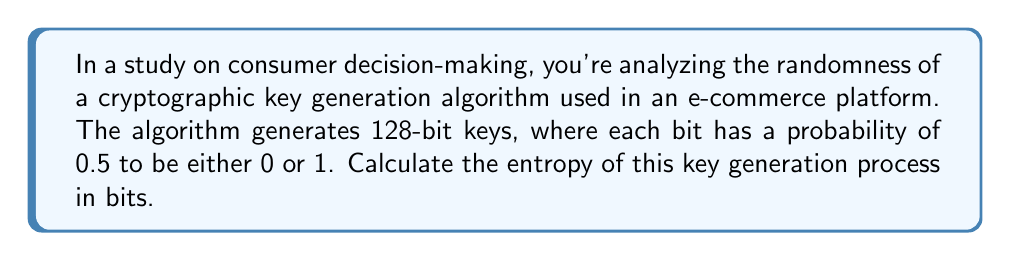Can you answer this question? To solve this problem, we'll follow these steps:

1. Understand the concept of entropy in cryptography:
   Entropy is a measure of randomness or unpredictability in a system. In cryptography, it quantifies the amount of information contained in a message or key.

2. Recall the formula for entropy:
   For a discrete random variable X with n possible outcomes, each with probability p(x_i), the entropy H(X) is given by:

   $$H(X) = -\sum_{i=1}^n p(x_i) \log_2(p(x_i))$$

3. Identify the relevant information:
   - We have a 128-bit key
   - Each bit has a probability of 0.5 to be 0 or 1

4. Calculate the entropy for a single bit:
   $$H(\text{bit}) = -[0.5 \log_2(0.5) + 0.5 \log_2(0.5)]$$
   $$= -[0.5 \cdot (-1) + 0.5 \cdot (-1)]$$
   $$= 1 \text{ bit}$$

5. Calculate the total entropy for the 128-bit key:
   Since each bit is independent and identically distributed, we can multiply the entropy of a single bit by the number of bits:

   $$H(\text{key}) = 128 \cdot H(\text{bit}) = 128 \cdot 1 = 128 \text{ bits}$$

Therefore, the entropy of the key generation process is 128 bits.
Answer: 128 bits 